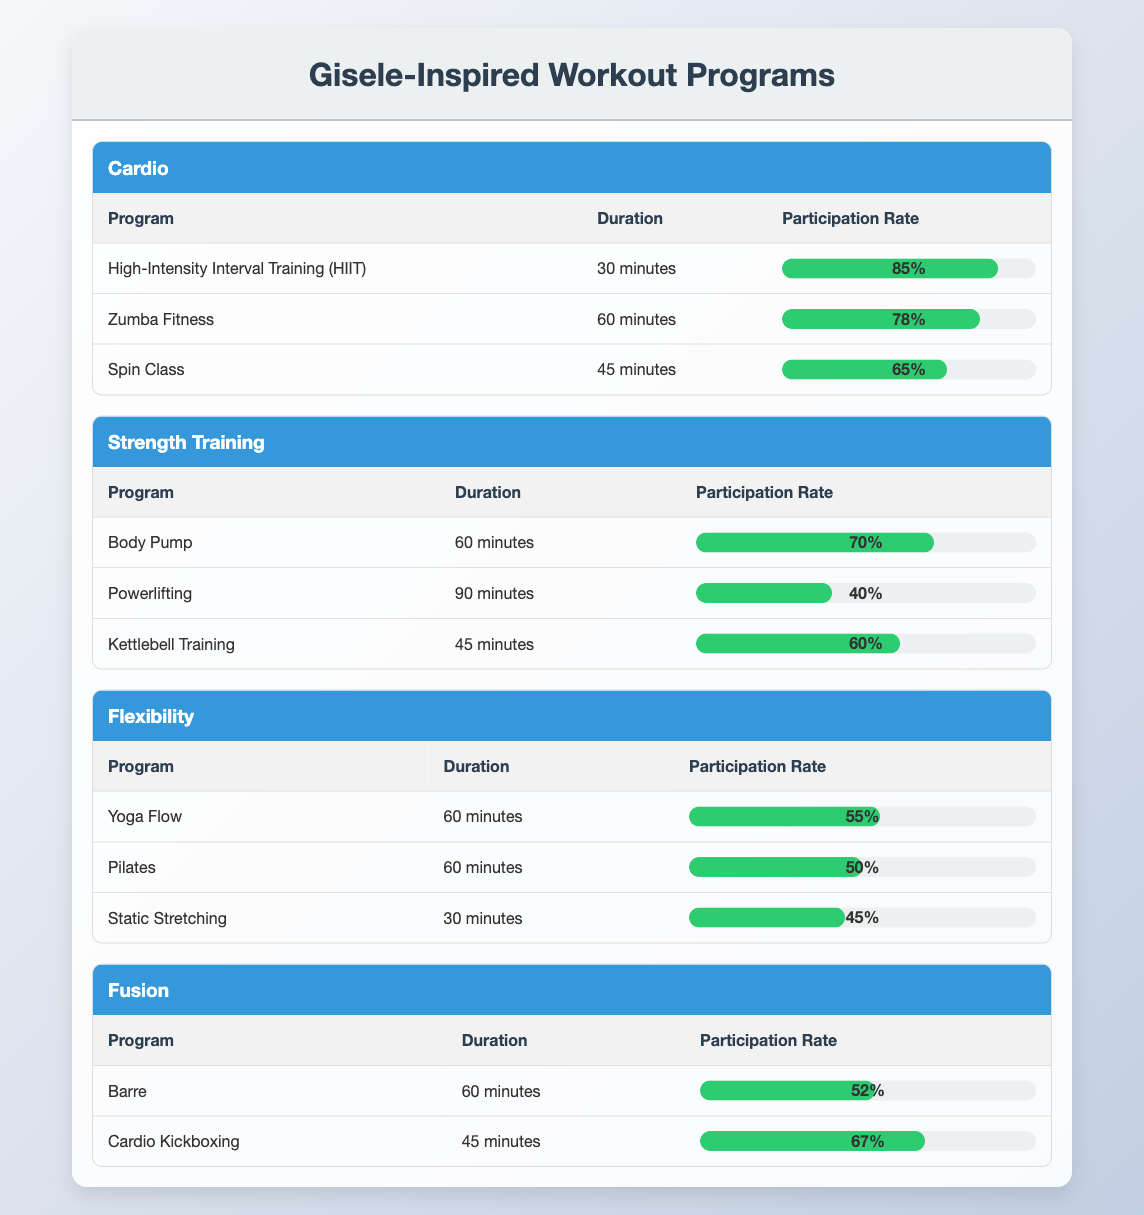What is the participation rate for High-Intensity Interval Training (HIIT)? The participation rate for HIIT is listed directly in the table under the Cardio section. It states 85%.
Answer: 85% Which strength training program has the highest participation rate? In the Strength Training section, Body Pump has the highest participation rate, which is 70%.
Answer: Body Pump What is the average participation rate of all cardio programs? To calculate the average, we add the participation rates of all cardio programs: 85 + 78 + 65 = 228. There are three programs, so the average is 228/3 = 76.
Answer: 76 Is the participation rate for Pilates higher than the participation rate for Static Stretching? The participation rate for Pilates is 50%, while the rate for Static Stretching is 45%. Since 50% is greater than 45%, the answer is yes.
Answer: Yes Which category has the lowest individual program participation rate? Looking at all the categories, Static Stretching has the lowest participation rate of 45%, making it the lowest individual program rate in the table.
Answer: Flexibility If you combine the participation rates of Kettlebell Training and Body Pump, what is the total? The participation rate for Kettlebell Training is 60%, and for Body Pump, it is 70%. Adding these gives us: 60 + 70 = 130.
Answer: 130 Are there more cardio programs with a participation rate above 70% than strength training programs with a similar rate? In the Cardio section, two programs have rates above 70%: HIIT (85%) and Zumba Fitness (78%). In Strength Training, only Body Pump (70%) meets this criteria. Yes, there are more cardio programs.
Answer: Yes What is the difference between the participation rates of Powerlifting and Cardio Kickboxing? The participation rate for Powerlifting is 40% and for Cardio Kickboxing it is 67%. The difference is calculated as 67 - 40 = 27.
Answer: 27 What is the total participation rate for all flexibility programs? We sum the participation rates of all flexibility programs: Yoga Flow (55%) + Pilates (50%) + Static Stretching (45%) = 150.
Answer: 150 